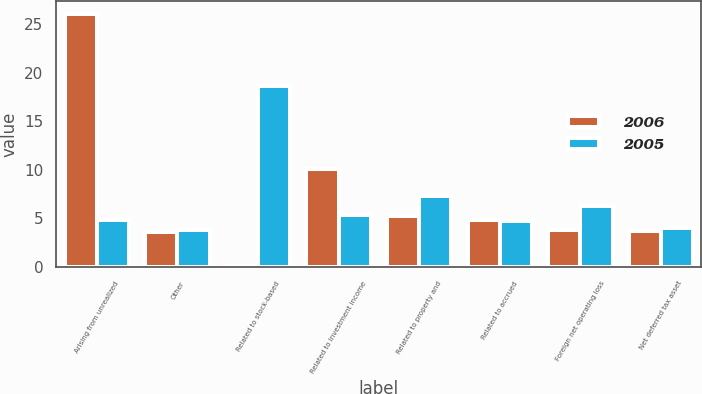<chart> <loc_0><loc_0><loc_500><loc_500><stacked_bar_chart><ecel><fcel>Arising from unrealized<fcel>Other<fcel>Related to stock-based<fcel>Related to investment income<fcel>Related to property and<fcel>Related to accrued<fcel>Foreign net operating loss<fcel>Net deferred tax asset<nl><fcel>2006<fcel>26.1<fcel>3.6<fcel>0.1<fcel>10.1<fcel>5.3<fcel>4.8<fcel>3.8<fcel>3.7<nl><fcel>2005<fcel>4.8<fcel>3.8<fcel>18.6<fcel>5.4<fcel>7.3<fcel>4.7<fcel>6.3<fcel>4<nl></chart> 